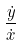<formula> <loc_0><loc_0><loc_500><loc_500>\frac { \dot { y } } { \dot { x } }</formula> 